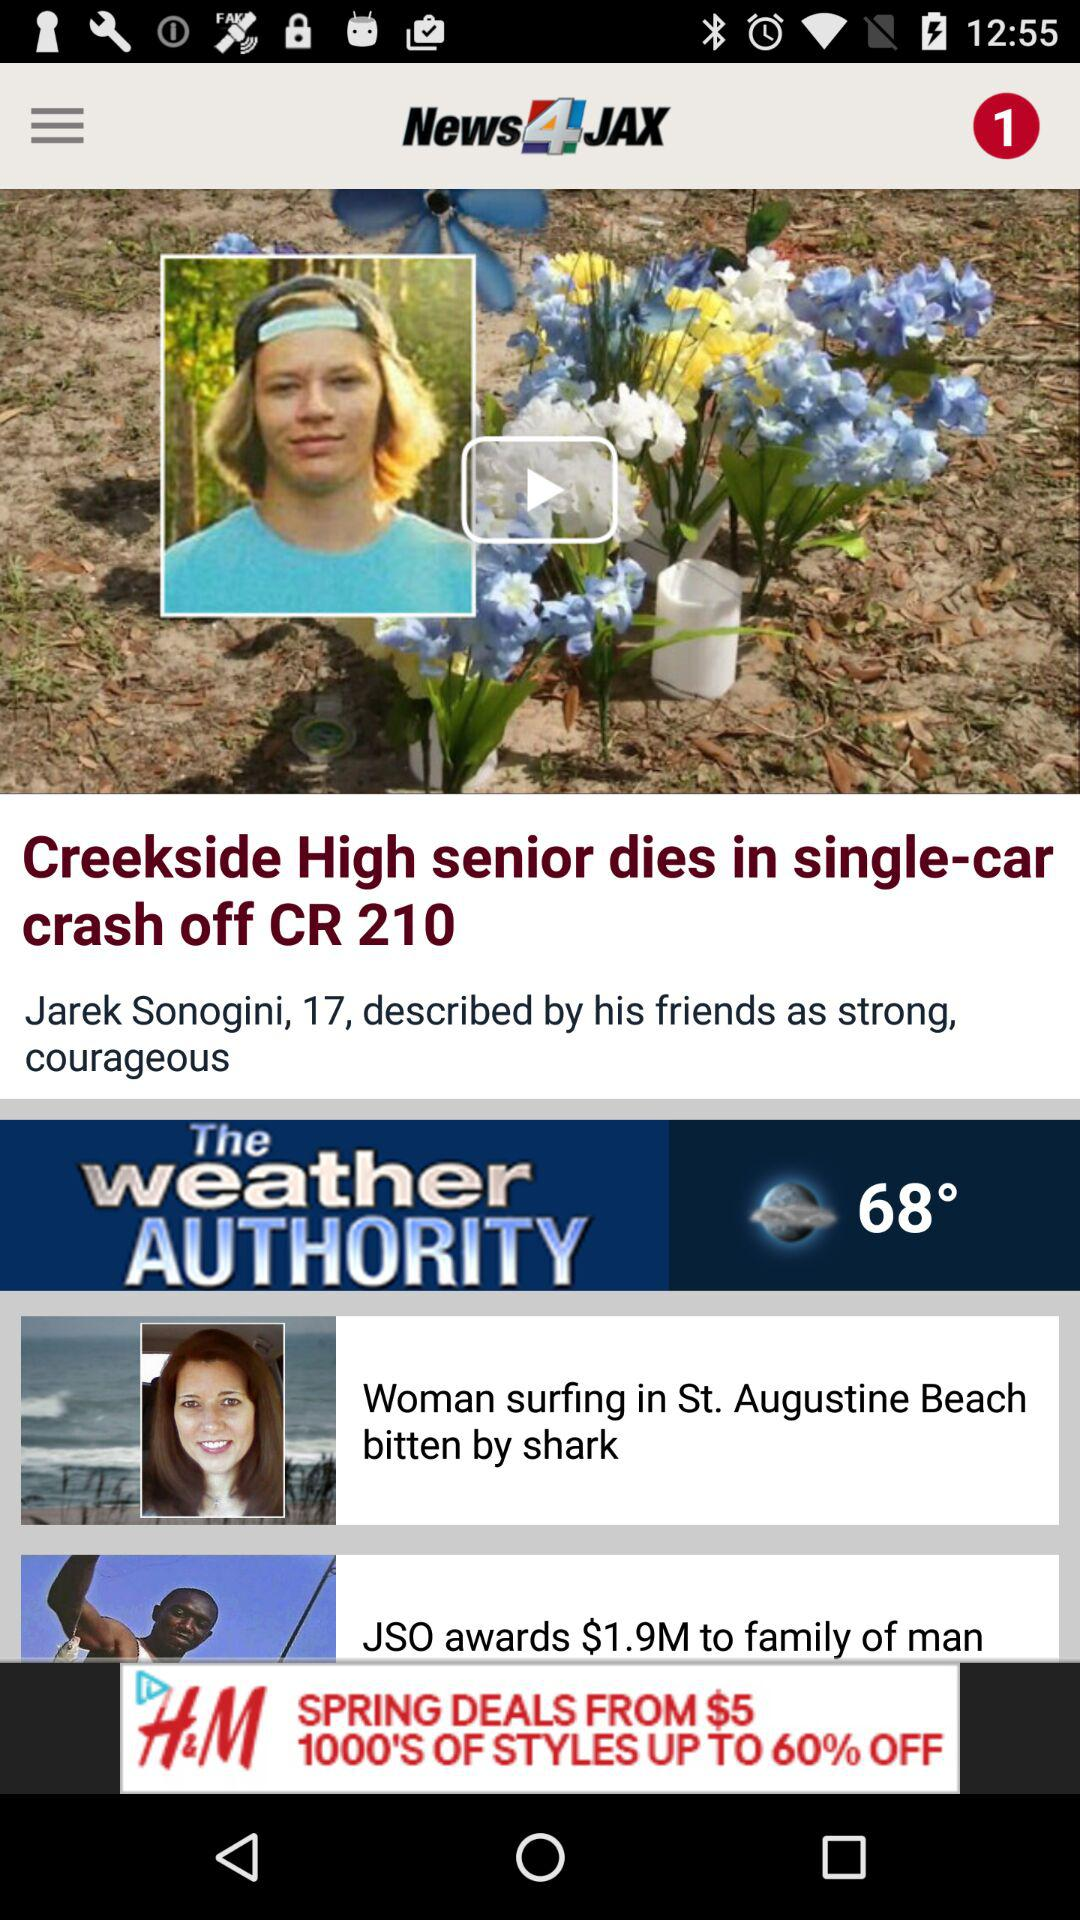What is the temperature? The temperature is 68°. 